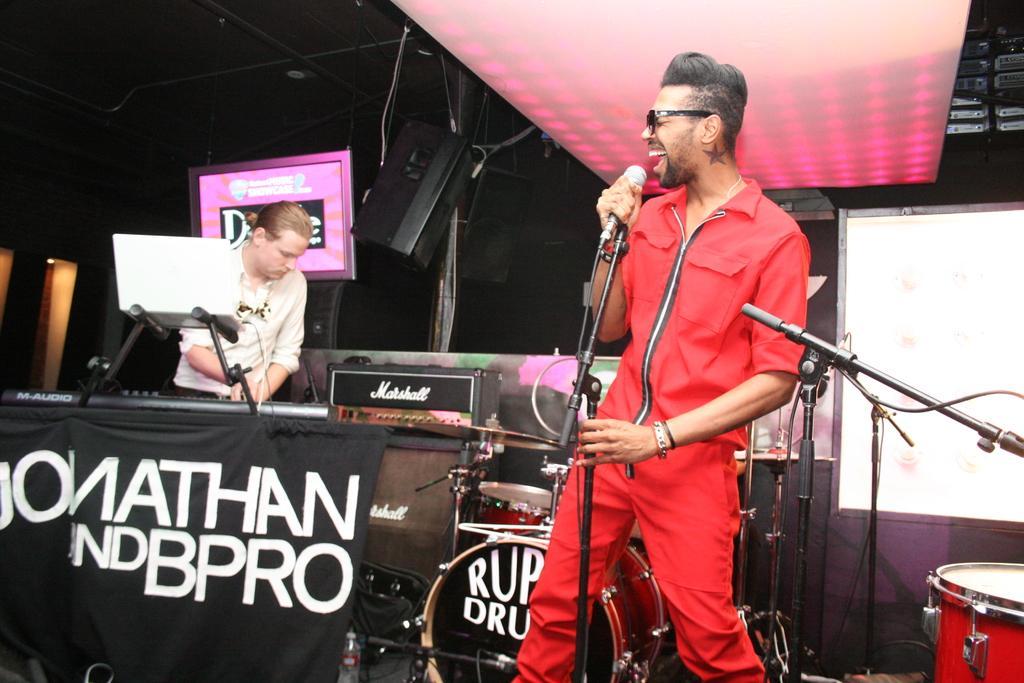Describe this image in one or two sentences. In this picture we can see two people, the one who is wearing red color shirt and pant and holding the mike is having the spectacles and the other guy wearing white color shirt is in front of a musical instrument and there is also a band and a speaker in the room. 